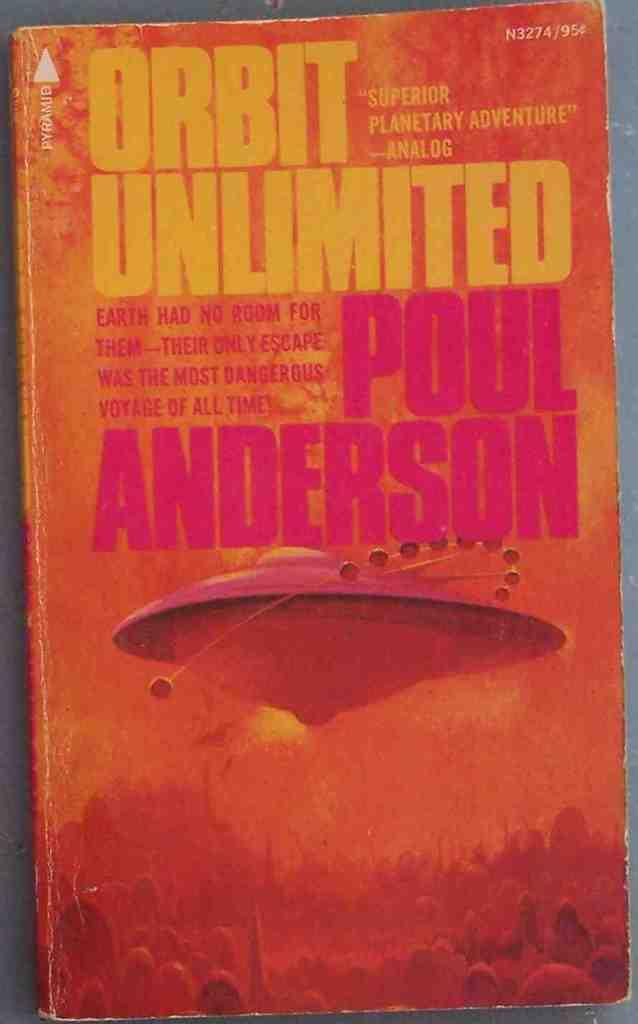<image>
Relay a brief, clear account of the picture shown. The book Orbit Unlimited was written by Poul Anderson. 